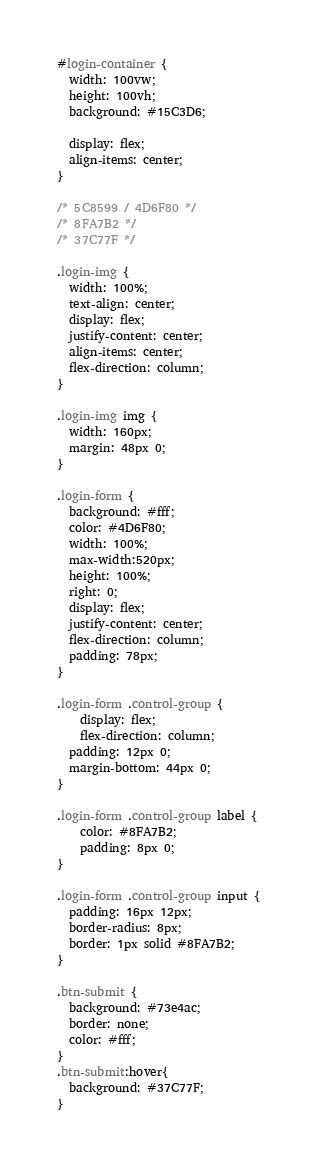<code> <loc_0><loc_0><loc_500><loc_500><_CSS_>#login-container {
  width: 100vw;
  height: 100vh;
  background: #15C3D6;

  display: flex;
  align-items: center;
}

/* 5C8599 / 4D6F80 */
/* 8FA7B2 */
/* 37C77F */

.login-img {
  width: 100%;
  text-align: center;
  display: flex;
  justify-content: center;
  align-items: center;
  flex-direction: column;
}

.login-img img {
  width: 160px;
  margin: 48px 0;
}

.login-form {
  background: #fff;
  color: #4D6F80;
  width: 100%;
  max-width:520px;
  height: 100%;
  right: 0;
  display: flex;
  justify-content: center;
  flex-direction: column;
  padding: 78px;
}

.login-form .control-group {
    display: flex;
    flex-direction: column;
  padding: 12px 0;
  margin-bottom: 44px 0;
}

.login-form .control-group label {
    color: #8FA7B2;
    padding: 8px 0;
}

.login-form .control-group input {
  padding: 16px 12px;
  border-radius: 8px;
  border: 1px solid #8FA7B2;
}

.btn-submit {
  background: #73e4ac;
  border: none;
  color: #fff;
}
.btn-submit:hover{ 
  background: #37C77F;
}</code> 